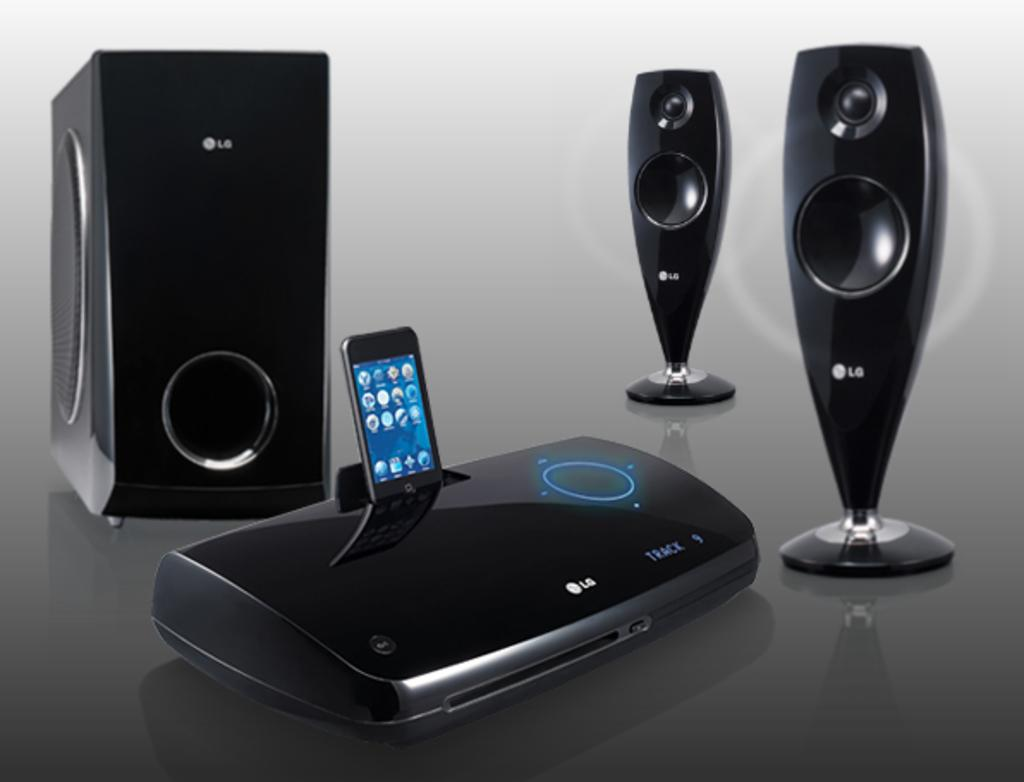<image>
Render a clear and concise summary of the photo. Different kinds of Lg speakers displayed on a black table. 